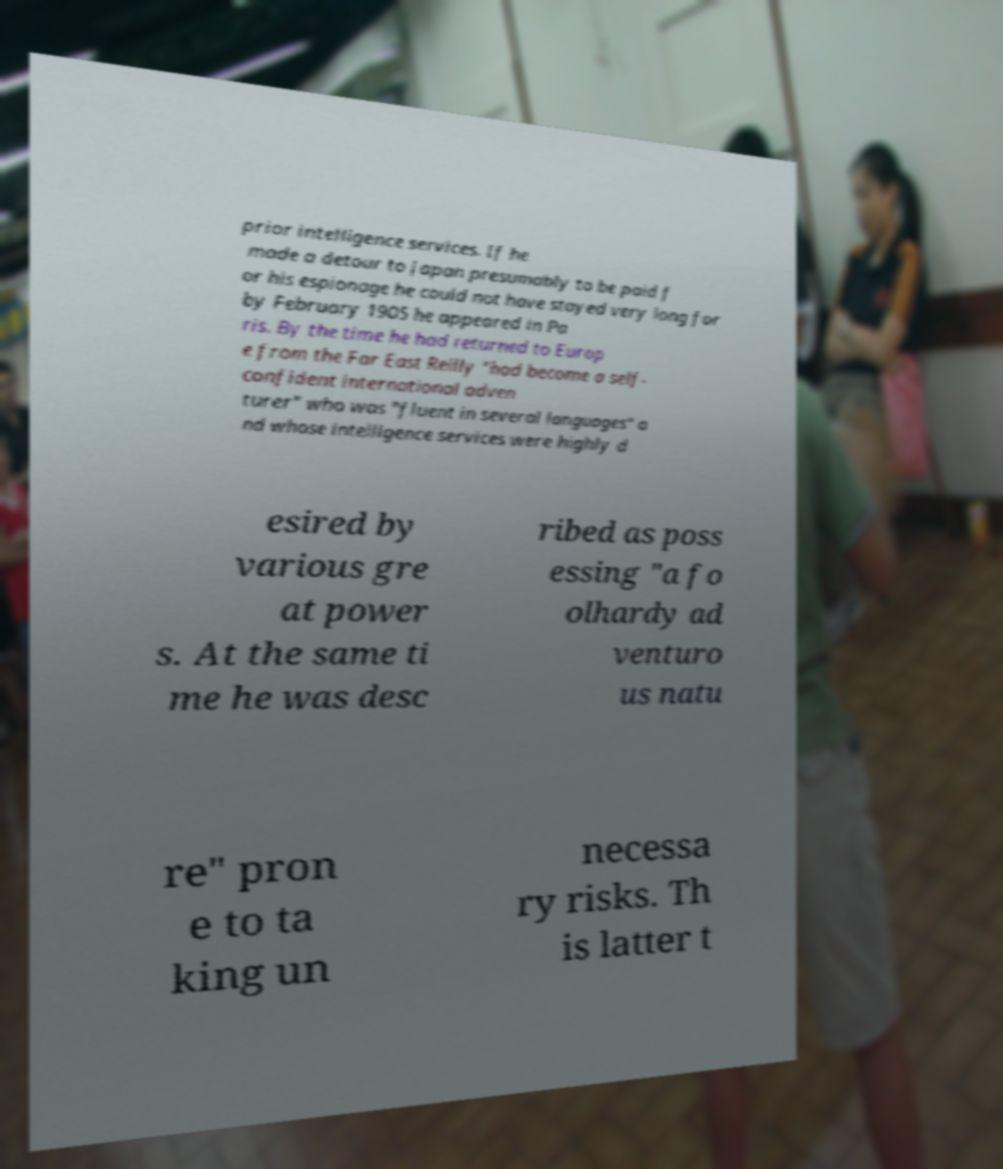Could you assist in decoding the text presented in this image and type it out clearly? prior intelligence services. If he made a detour to Japan presumably to be paid f or his espionage he could not have stayed very long for by February 1905 he appeared in Pa ris. By the time he had returned to Europ e from the Far East Reilly "had become a self- confident international adven turer" who was "fluent in several languages" a nd whose intelligence services were highly d esired by various gre at power s. At the same ti me he was desc ribed as poss essing "a fo olhardy ad venturo us natu re" pron e to ta king un necessa ry risks. Th is latter t 